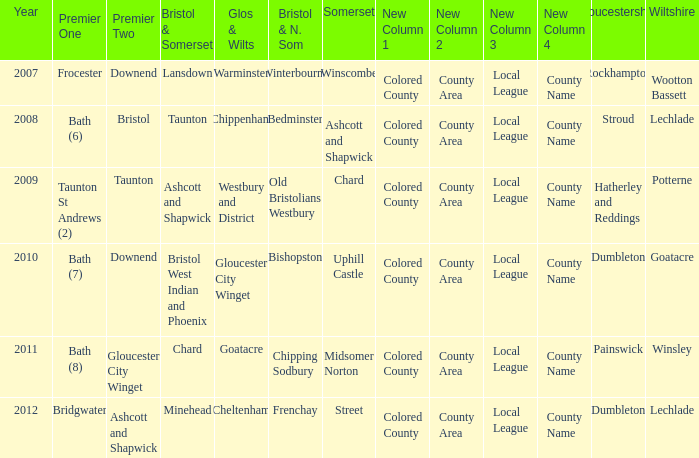What is the bristol & n. som where the somerset is ashcott and shapwick? Bedminster. 